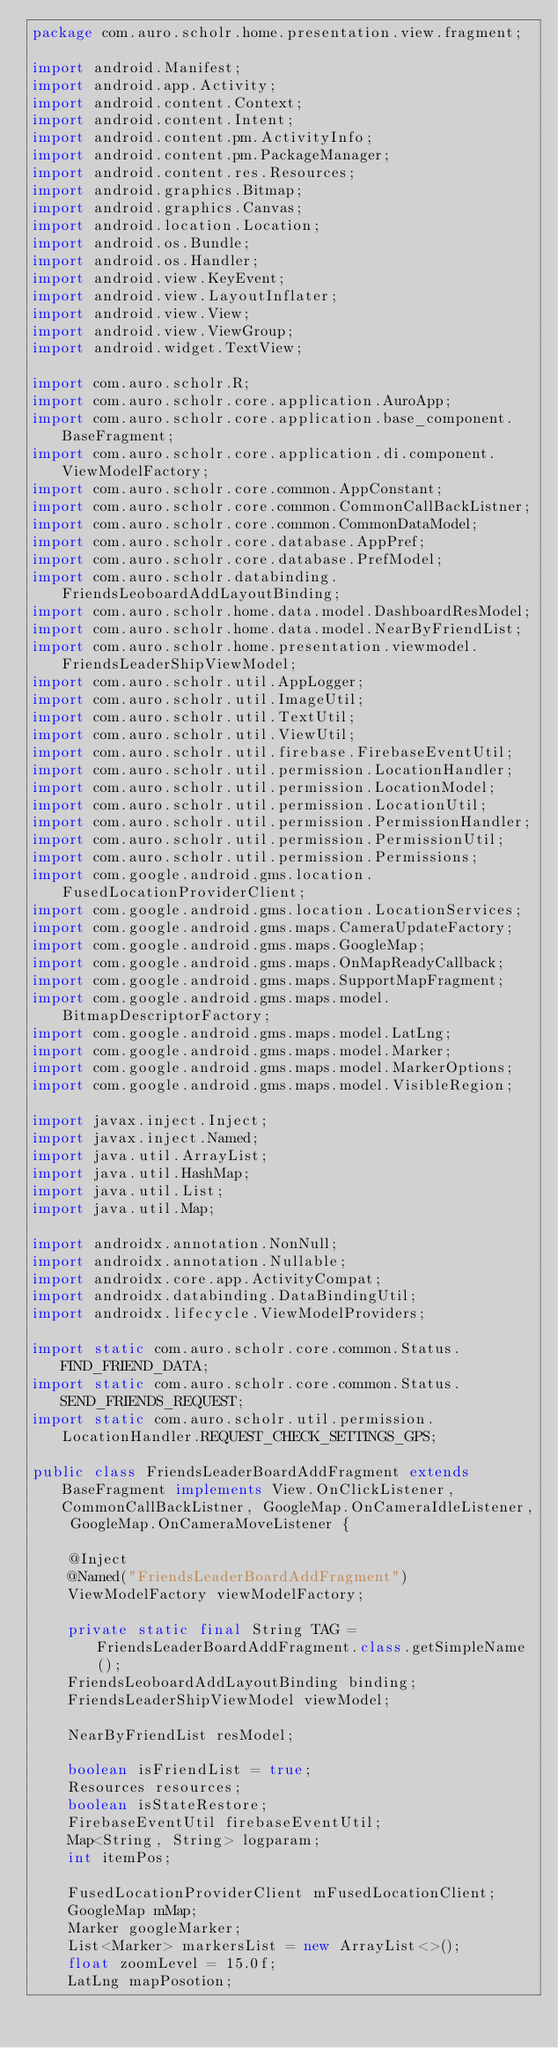<code> <loc_0><loc_0><loc_500><loc_500><_Java_>package com.auro.scholr.home.presentation.view.fragment;

import android.Manifest;
import android.app.Activity;
import android.content.Context;
import android.content.Intent;
import android.content.pm.ActivityInfo;
import android.content.pm.PackageManager;
import android.content.res.Resources;
import android.graphics.Bitmap;
import android.graphics.Canvas;
import android.location.Location;
import android.os.Bundle;
import android.os.Handler;
import android.view.KeyEvent;
import android.view.LayoutInflater;
import android.view.View;
import android.view.ViewGroup;
import android.widget.TextView;

import com.auro.scholr.R;
import com.auro.scholr.core.application.AuroApp;
import com.auro.scholr.core.application.base_component.BaseFragment;
import com.auro.scholr.core.application.di.component.ViewModelFactory;
import com.auro.scholr.core.common.AppConstant;
import com.auro.scholr.core.common.CommonCallBackListner;
import com.auro.scholr.core.common.CommonDataModel;
import com.auro.scholr.core.database.AppPref;
import com.auro.scholr.core.database.PrefModel;
import com.auro.scholr.databinding.FriendsLeoboardAddLayoutBinding;
import com.auro.scholr.home.data.model.DashboardResModel;
import com.auro.scholr.home.data.model.NearByFriendList;
import com.auro.scholr.home.presentation.viewmodel.FriendsLeaderShipViewModel;
import com.auro.scholr.util.AppLogger;
import com.auro.scholr.util.ImageUtil;
import com.auro.scholr.util.TextUtil;
import com.auro.scholr.util.ViewUtil;
import com.auro.scholr.util.firebase.FirebaseEventUtil;
import com.auro.scholr.util.permission.LocationHandler;
import com.auro.scholr.util.permission.LocationModel;
import com.auro.scholr.util.permission.LocationUtil;
import com.auro.scholr.util.permission.PermissionHandler;
import com.auro.scholr.util.permission.PermissionUtil;
import com.auro.scholr.util.permission.Permissions;
import com.google.android.gms.location.FusedLocationProviderClient;
import com.google.android.gms.location.LocationServices;
import com.google.android.gms.maps.CameraUpdateFactory;
import com.google.android.gms.maps.GoogleMap;
import com.google.android.gms.maps.OnMapReadyCallback;
import com.google.android.gms.maps.SupportMapFragment;
import com.google.android.gms.maps.model.BitmapDescriptorFactory;
import com.google.android.gms.maps.model.LatLng;
import com.google.android.gms.maps.model.Marker;
import com.google.android.gms.maps.model.MarkerOptions;
import com.google.android.gms.maps.model.VisibleRegion;

import javax.inject.Inject;
import javax.inject.Named;
import java.util.ArrayList;
import java.util.HashMap;
import java.util.List;
import java.util.Map;

import androidx.annotation.NonNull;
import androidx.annotation.Nullable;
import androidx.core.app.ActivityCompat;
import androidx.databinding.DataBindingUtil;
import androidx.lifecycle.ViewModelProviders;

import static com.auro.scholr.core.common.Status.FIND_FRIEND_DATA;
import static com.auro.scholr.core.common.Status.SEND_FRIENDS_REQUEST;
import static com.auro.scholr.util.permission.LocationHandler.REQUEST_CHECK_SETTINGS_GPS;

public class FriendsLeaderBoardAddFragment extends BaseFragment implements View.OnClickListener, CommonCallBackListner, GoogleMap.OnCameraIdleListener, GoogleMap.OnCameraMoveListener {

    @Inject
    @Named("FriendsLeaderBoardAddFragment")
    ViewModelFactory viewModelFactory;

    private static final String TAG = FriendsLeaderBoardAddFragment.class.getSimpleName();
    FriendsLeoboardAddLayoutBinding binding;
    FriendsLeaderShipViewModel viewModel;

    NearByFriendList resModel;

    boolean isFriendList = true;
    Resources resources;
    boolean isStateRestore;
    FirebaseEventUtil firebaseEventUtil;
    Map<String, String> logparam;
    int itemPos;

    FusedLocationProviderClient mFusedLocationClient;
    GoogleMap mMap;
    Marker googleMarker;
    List<Marker> markersList = new ArrayList<>();
    float zoomLevel = 15.0f;
    LatLng mapPosotion;</code> 